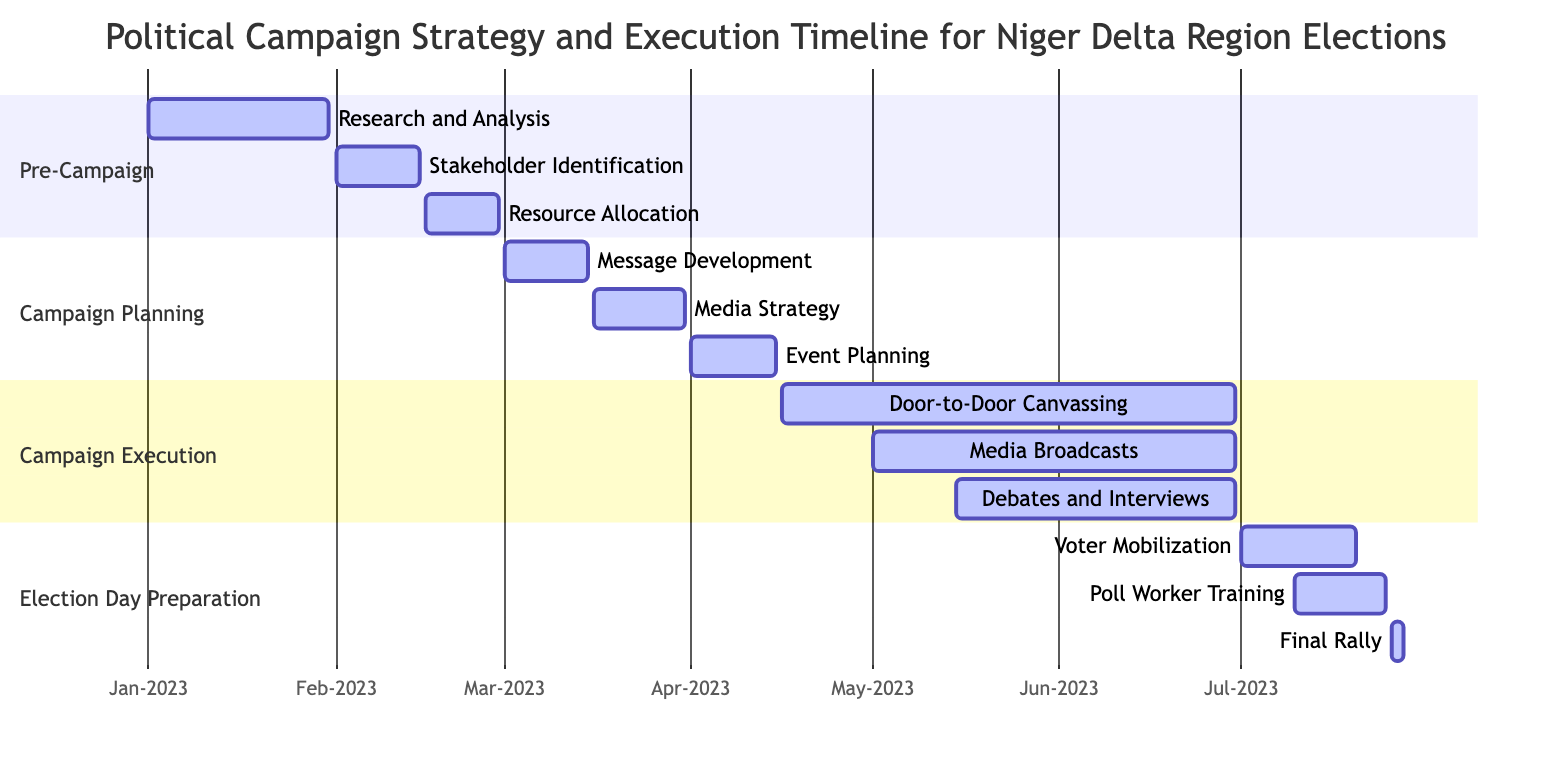What is the duration of the Task "Research and Analysis"? The task "Research and Analysis" starts on January 1, 2023, and ends on January 31, 2023. By calculating the difference, the duration is 31 days.
Answer: 31 days Which task comes immediately after "Stakeholder Identification"? The task "Stakeholder Identification" ends on February 15, 2023, and the next task, "Resource Allocation," starts on February 16, 2023. Therefore, "Resource Allocation" comes immediately after "Stakeholder Identification."
Answer: Resource Allocation How many tasks are under the "Campaign Planning" phase? Under the "Campaign Planning" phase, there are three tasks listed: "Message Development," "Media Strategy," and "Event Planning." Thus, the total is three tasks.
Answer: 3 What is the overlapping period for "Media Broadcasts" and "Debates and Interviews"? "Media Broadcasts" runs from May 1, 2023, to June 30, 2023, while "Debates and Interviews" runs from May 15, 2023, to June 30, 2023. The overlapping period is from May 15 to June 30.
Answer: May 15 to June 30 Which task has the latest end date, and what is that date? Examining all the tasks, "Door-to-Door Canvassing," "Media Broadcasts," and "Debates and Interviews" all end on June 30, 2023. However, the "Final Rally" ends later on July 28, 2023. Therefore, the latest end date belongs to "Final Rally."
Answer: July 28, 2023 How many days are allocated for "Voter Mobilization"? "Voter Mobilization" starts on July 1, 2023, and ends on July 20, 2023. Calculating the difference, it lasts for 20 days.
Answer: 20 days What phase includes the task "Event Planning"? The task "Event Planning" is listed under the "Campaign Planning" phase according to the diagram data.
Answer: Campaign Planning Which two tasks share the same start date of July 10, 2023? According to the diagram, both "Poll Worker Training" and "Voter Mobilization" start on July 10, 2023.
Answer: Poll Worker Training, Voter Mobilization 